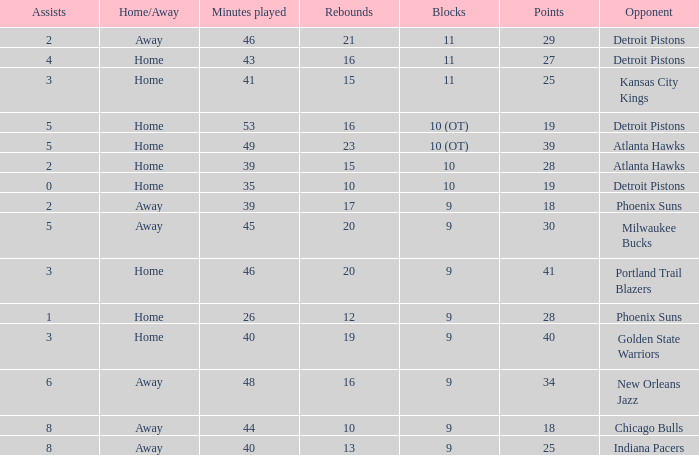How many points were there when there were less than 16 rebounds and 5 assists? 0.0. 